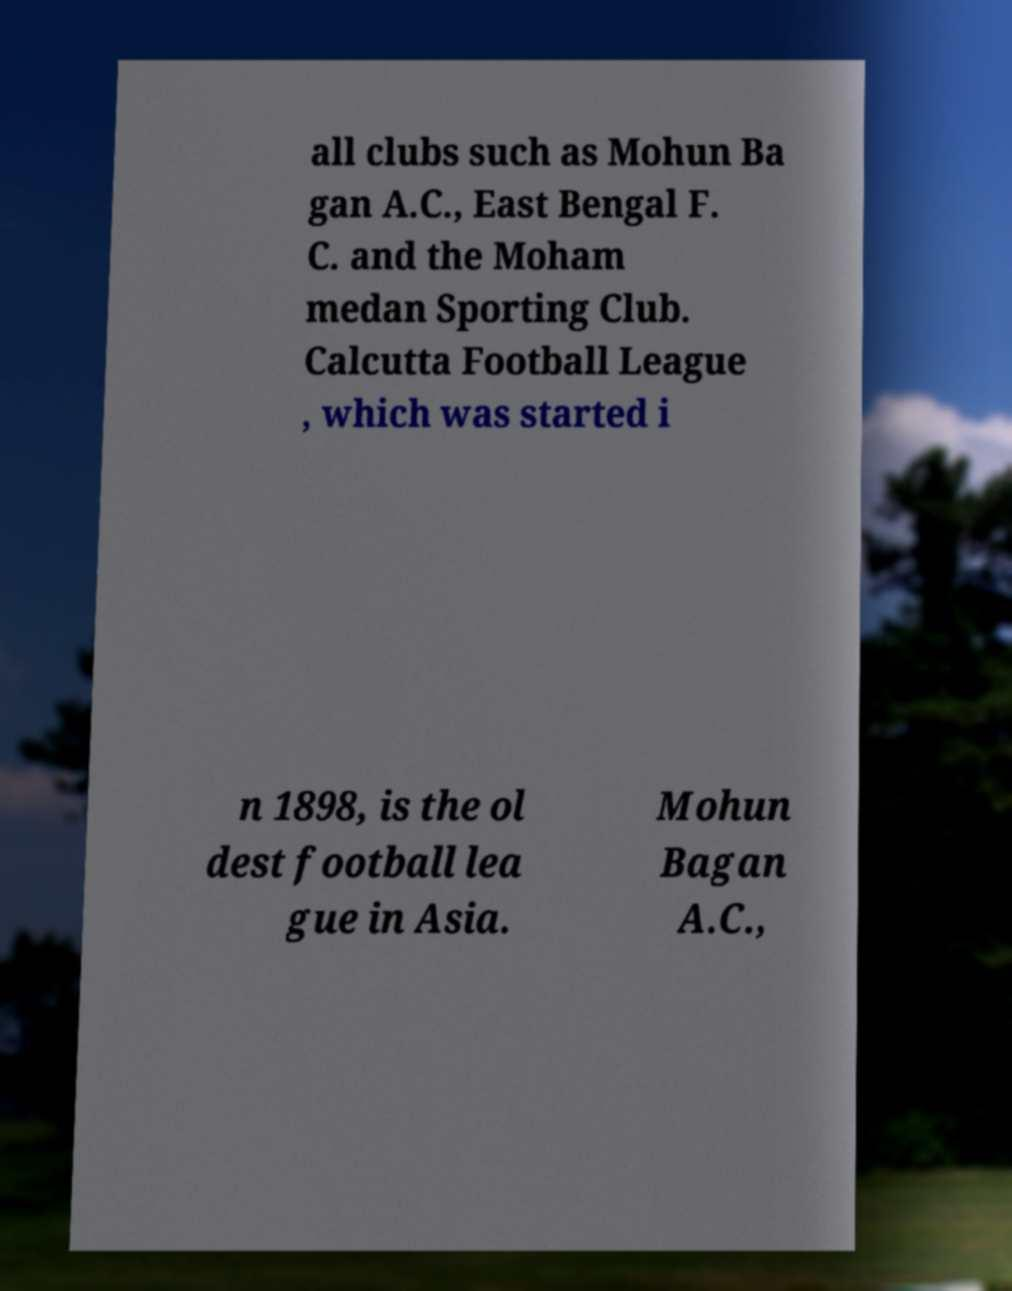For documentation purposes, I need the text within this image transcribed. Could you provide that? all clubs such as Mohun Ba gan A.C., East Bengal F. C. and the Moham medan Sporting Club. Calcutta Football League , which was started i n 1898, is the ol dest football lea gue in Asia. Mohun Bagan A.C., 